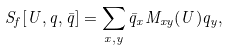<formula> <loc_0><loc_0><loc_500><loc_500>S _ { f } [ U , q , \bar { q } ] = \sum _ { x , y } \bar { q } _ { x } M _ { x y } ( U ) q _ { y } ,</formula> 